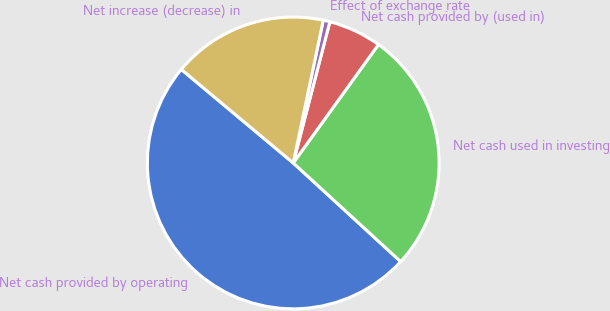<chart> <loc_0><loc_0><loc_500><loc_500><pie_chart><fcel>Net cash provided by operating<fcel>Net cash used in investing<fcel>Net cash provided by (used in)<fcel>Effect of exchange rate<fcel>Net increase (decrease) in<nl><fcel>49.26%<fcel>26.89%<fcel>5.89%<fcel>0.74%<fcel>17.22%<nl></chart> 